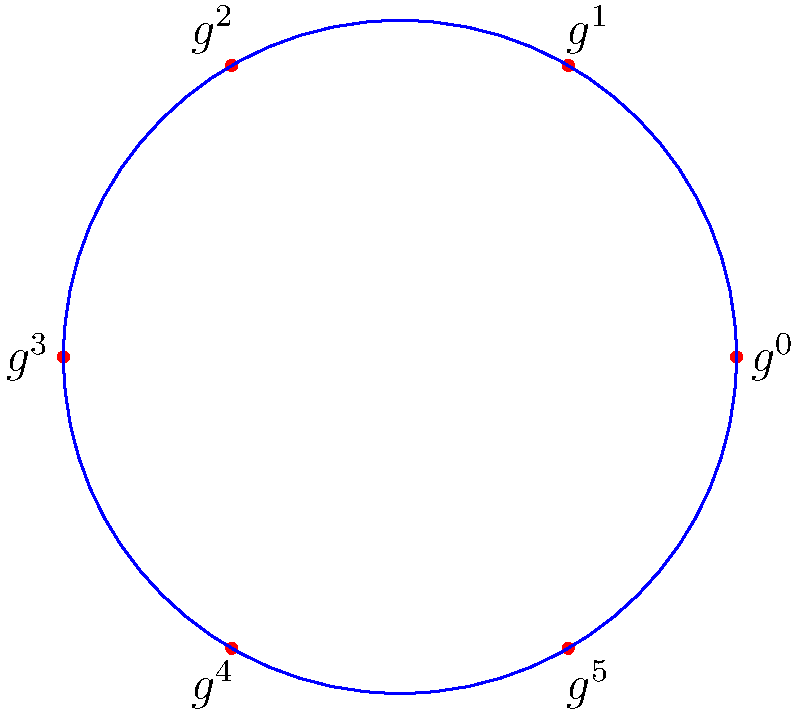In a cyclic group of order 6 represented by the circular diagram above, where $g$ is the generator, what is the order of the element $g^4$? To determine the order of $g^4$ in a cyclic group of order 6, we can follow these steps:

1. Recall that in a cyclic group of order 6, we have elements $\{e, g, g^2, g^3, g^4, g^5\}$, where $e$ is the identity element and $g$ is the generator.

2. The order of an element is the smallest positive integer $k$ such that $(g^4)^k = e$.

3. Let's calculate the powers of $g^4$:
   - $(g^4)^1 = g^4$
   - $(g^4)^2 = g^8 = g^2$ (since $g^6 = e$ in a group of order 6)
   - $(g^4)^3 = g^{12} = e$ (since $g^6 = e$ and $g^{12} = (g^6)^2 = e^2 = e$)

4. We see that $(g^4)^3 = e$, and this is the smallest positive integer $k$ for which this equality holds.

Therefore, the order of $g^4$ is 3.
Answer: 3 